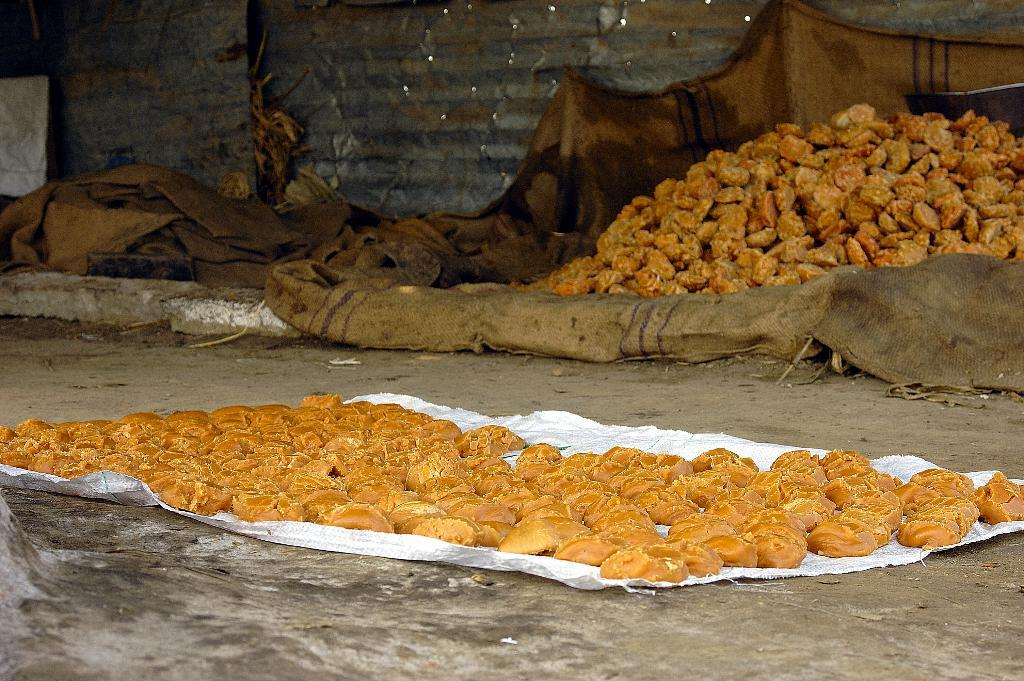What is the main subject of the image? The main subject of the image is food items arranged on a bag cover. Where is the bag cover located? The bag cover is on the floor. What else can be seen in the background of the image? There are food items and bag covers in the background, as well as a wall. Can you hear a whistle in the image? There is no mention of a whistle in the image, so it cannot be heard. 